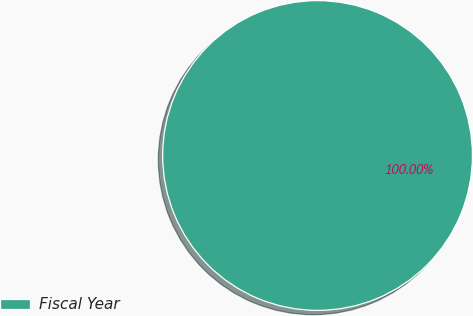Convert chart. <chart><loc_0><loc_0><loc_500><loc_500><pie_chart><fcel>Fiscal Year<nl><fcel>100.0%<nl></chart> 